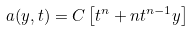Convert formula to latex. <formula><loc_0><loc_0><loc_500><loc_500>a ( y , t ) = C \left [ t ^ { n } + n t ^ { n - 1 } y \right ]</formula> 